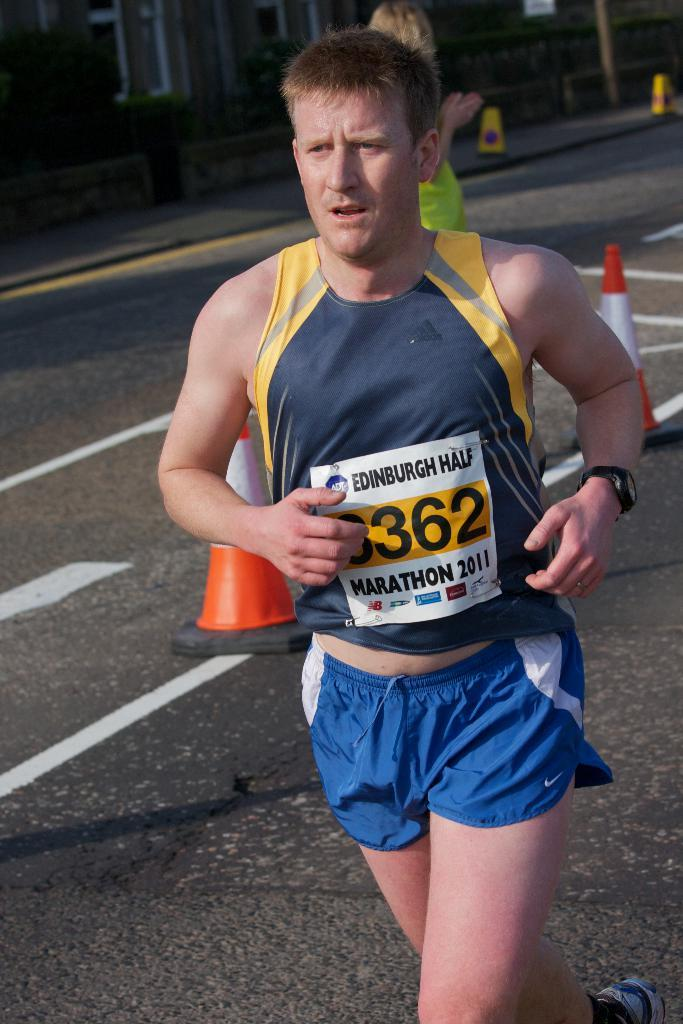<image>
Write a terse but informative summary of the picture. Runner wearing a tag taht has the number 3362 on it. 